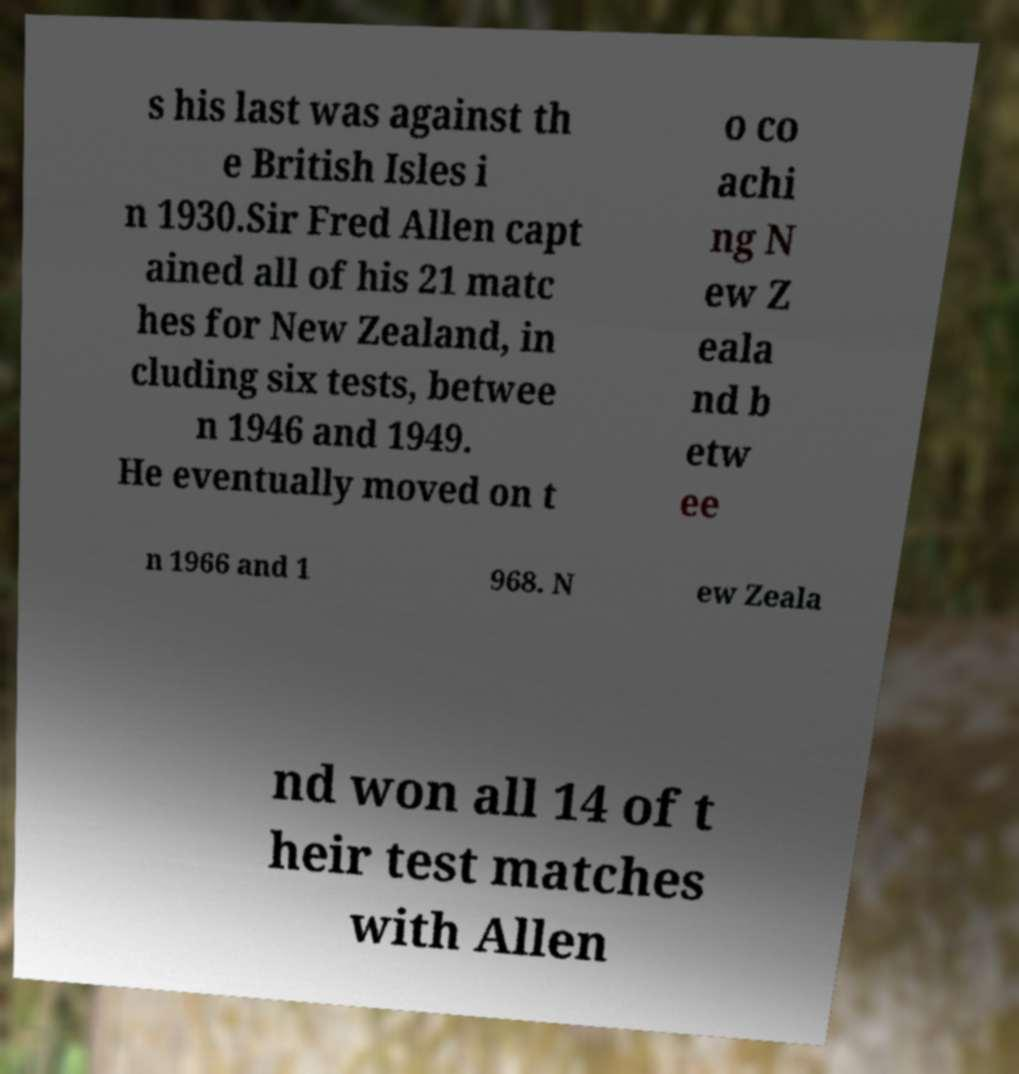Please read and relay the text visible in this image. What does it say? s his last was against th e British Isles i n 1930.Sir Fred Allen capt ained all of his 21 matc hes for New Zealand, in cluding six tests, betwee n 1946 and 1949. He eventually moved on t o co achi ng N ew Z eala nd b etw ee n 1966 and 1 968. N ew Zeala nd won all 14 of t heir test matches with Allen 